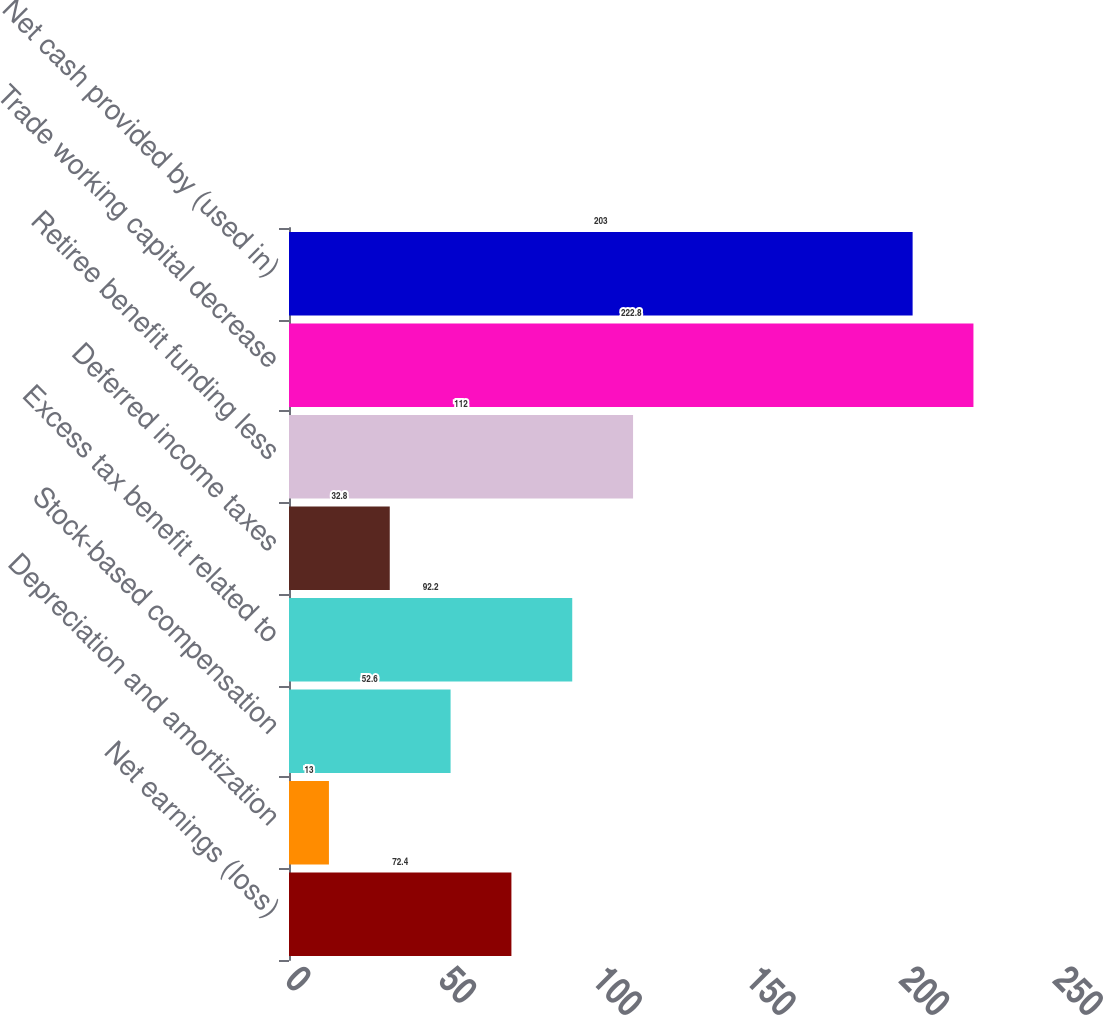Convert chart. <chart><loc_0><loc_0><loc_500><loc_500><bar_chart><fcel>Net earnings (loss)<fcel>Depreciation and amortization<fcel>Stock-based compensation<fcel>Excess tax benefit related to<fcel>Deferred income taxes<fcel>Retiree benefit funding less<fcel>Trade working capital decrease<fcel>Net cash provided by (used in)<nl><fcel>72.4<fcel>13<fcel>52.6<fcel>92.2<fcel>32.8<fcel>112<fcel>222.8<fcel>203<nl></chart> 